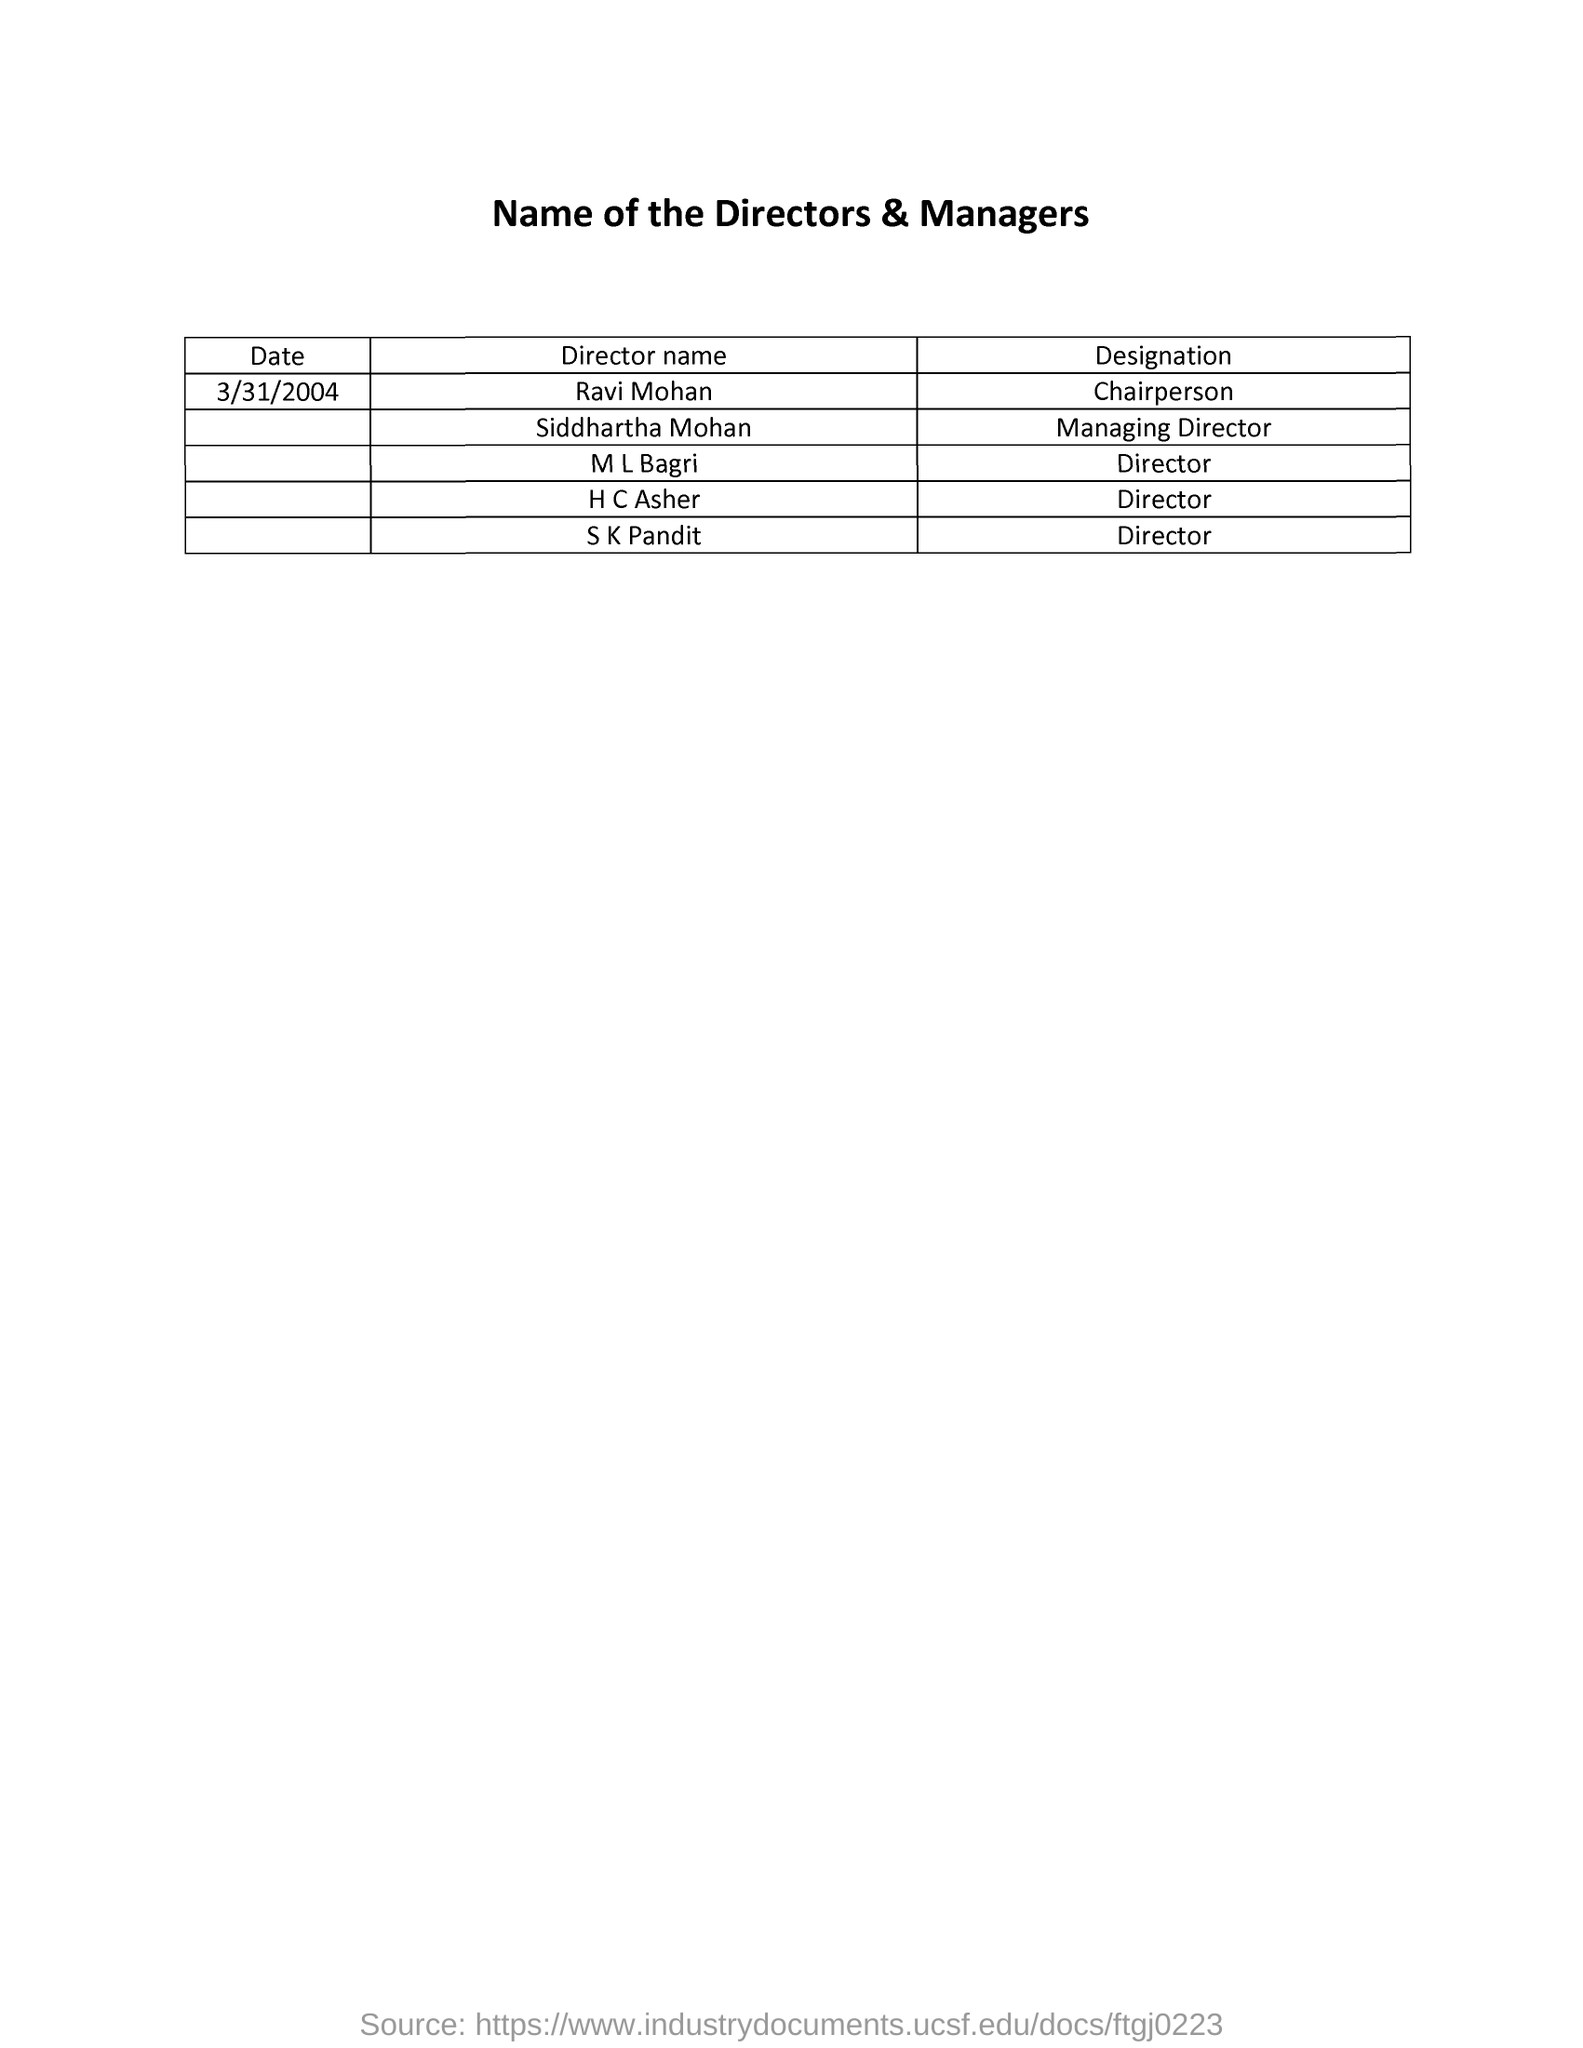Highlight a few significant elements in this photo. The title of the document is [insert title here], and the names of the directors and managers are [insert names here]. The date mentioned in the document is March 31, 2004. The designation of Ravi Mohan is Chairperson. 